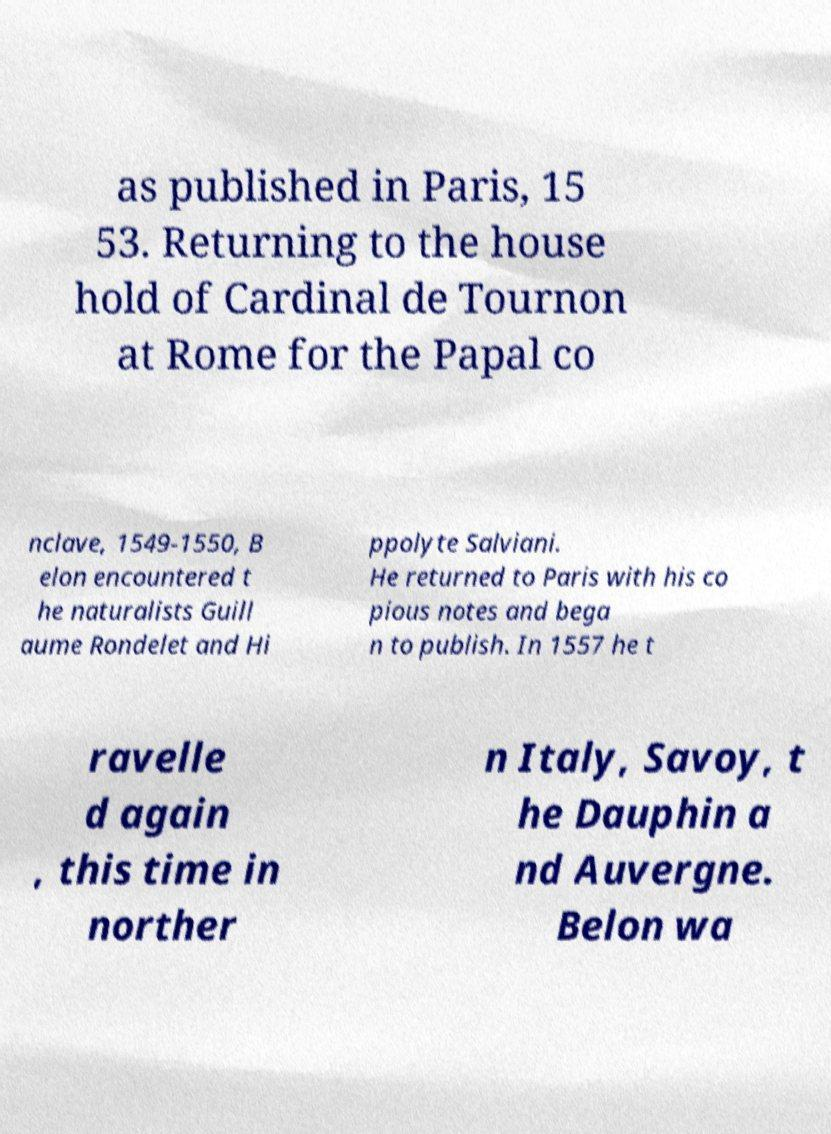There's text embedded in this image that I need extracted. Can you transcribe it verbatim? as published in Paris, 15 53. Returning to the house hold of Cardinal de Tournon at Rome for the Papal co nclave, 1549-1550, B elon encountered t he naturalists Guill aume Rondelet and Hi ppolyte Salviani. He returned to Paris with his co pious notes and bega n to publish. In 1557 he t ravelle d again , this time in norther n Italy, Savoy, t he Dauphin a nd Auvergne. Belon wa 